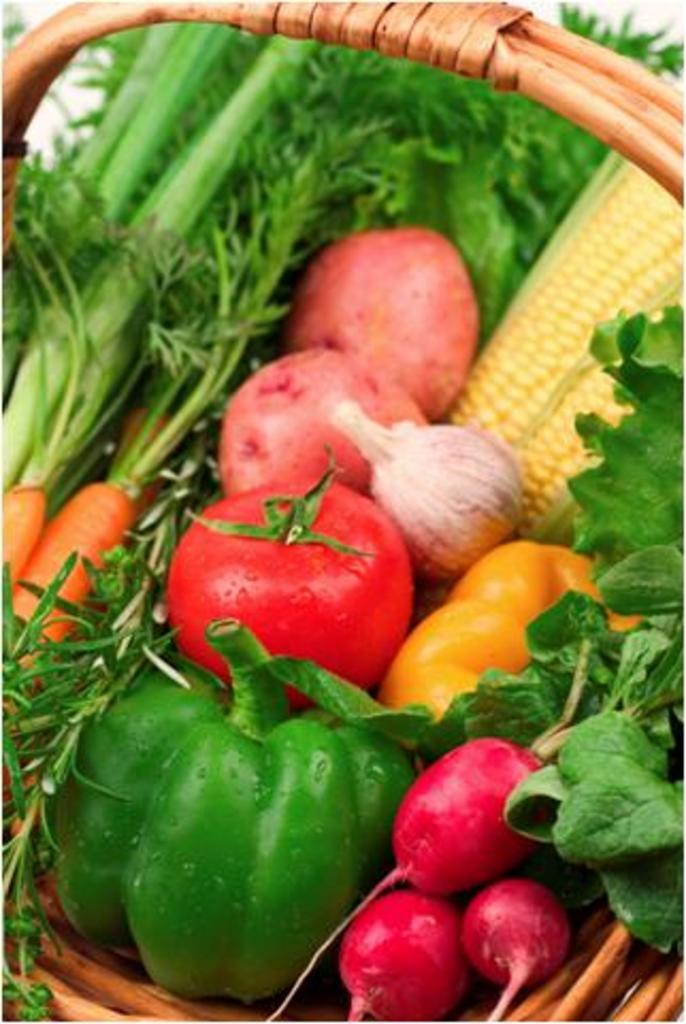What type of vegetables can be seen in the image? There are carrots, capsicums, a tomato, sweet corn, and leaves visible in the image. How are the vegetables arranged in the image? The vegetables are in a basket in the image. Can you identify any other vegetables in the image besides the ones mentioned? No, the provided facts only mention carrots, capsicums, a tomato, sweet corn, and leaves. What type of bells can be heard ringing in the image? There are no bells present in the image, and therefore no sound can be heard. 